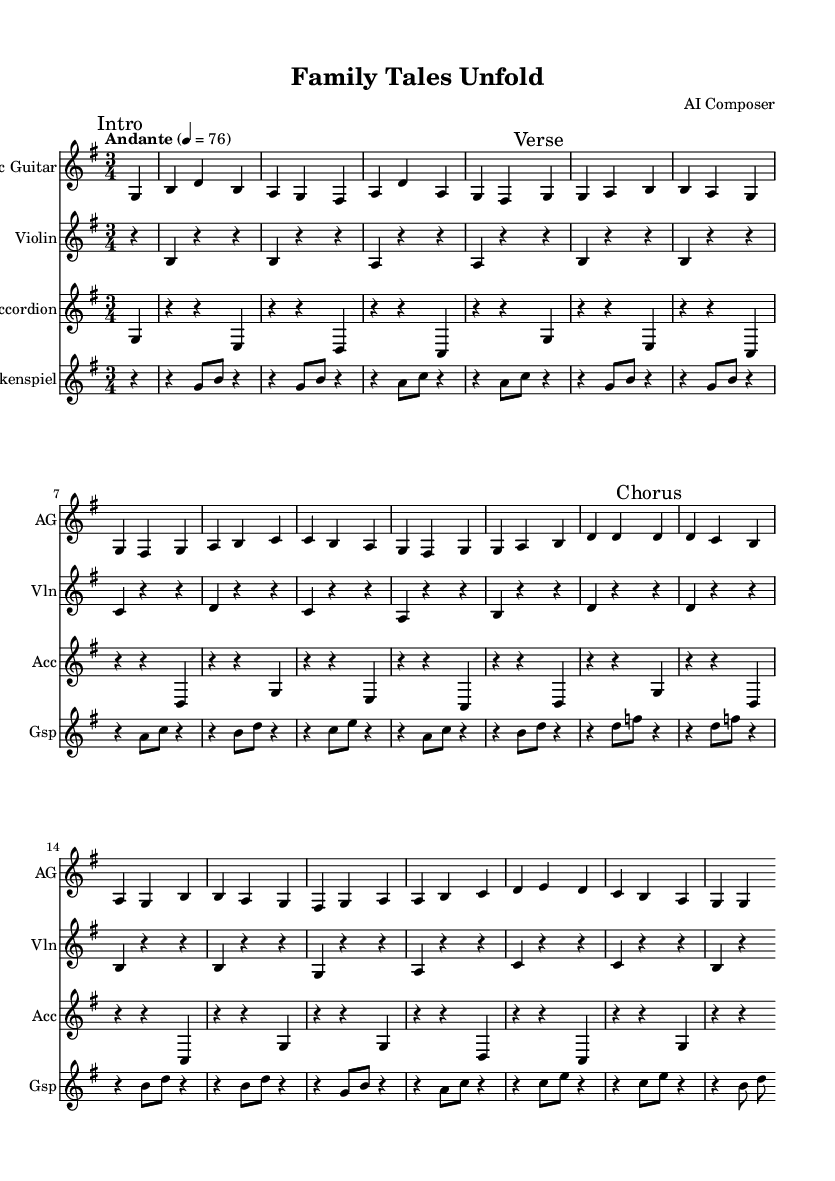What is the key signature of this music? The key signature is G major, which has one sharp (F#). This is determined by looking at the key signature indicated on the staff at the beginning of the sheet music.
Answer: G major What is the time signature of the piece? The time signature is 3/4, which means there are three beats in each measure and the quarter note gets one beat. This is indicated at the start of the music.
Answer: 3/4 What is the tempo marking of this piece? The tempo marking is "Andante," which suggests a moderately slow pace. This is found above the staff in the tempo designation.
Answer: Andante How many measures are in the chorus section? The chorus section contains eight measures, which can be counted by analyzing the sequence of notes and measures labeled as "Chorus."
Answer: 8 Which instrument plays the melody in the verse section? The melody in the verse section is primarily played by the acoustic guitar, as it has the main thematic material and is indicated by the staff labeled for it.
Answer: Acoustic Guitar What is the dynamic marking for the violin throughout the sheet music? The dynamic marking for the violin is set as "dynamicUp," which indicates a general direction for the dynamics to be played loud or expressive. Since it does not specify an exact dynamic level, it suggests a gentle or moderate expression.
Answer: dynamicUp What type of music is represented by this piece? This piece can be classified as "nostalgic indie folk," reflective of family storytelling traditions, as indicated by its structure, themes, and instrumentation that evoke emotional connection and storytelling elements.
Answer: Nostalgic indie folk 